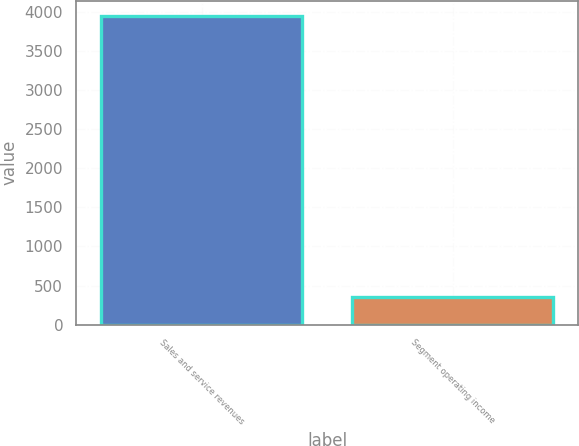Convert chart to OTSL. <chart><loc_0><loc_0><loc_500><loc_500><bar_chart><fcel>Sales and service revenues<fcel>Segment operating income<nl><fcel>3940<fcel>360<nl></chart> 